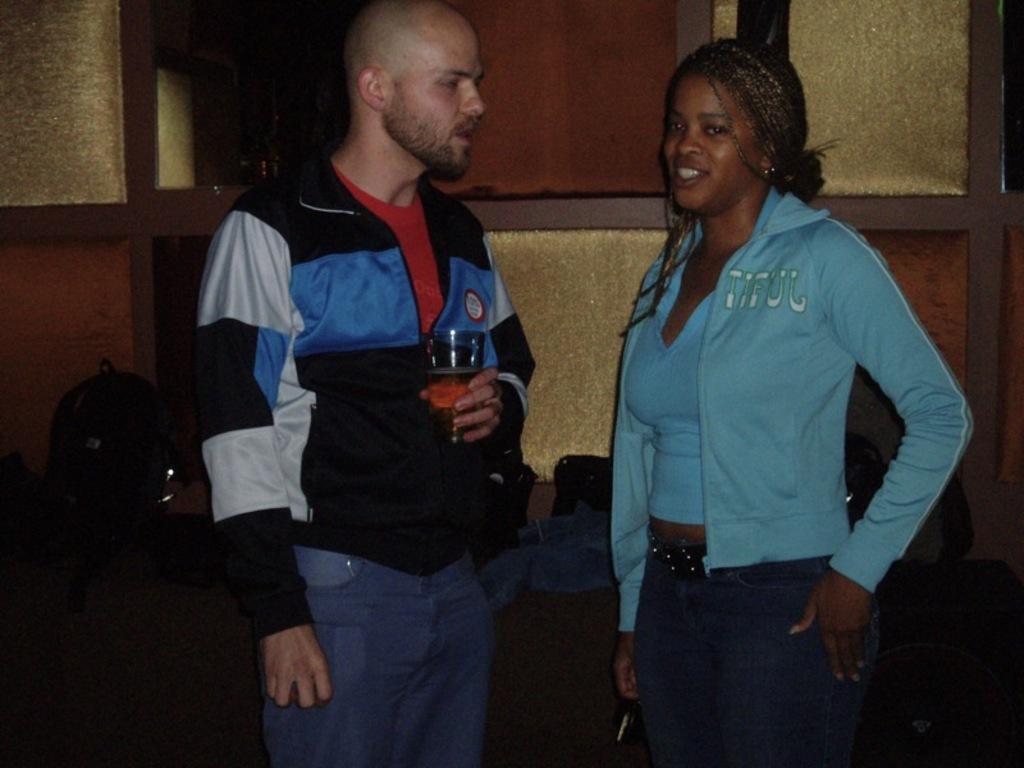Describe this image in one or two sentences. In this picture we can see a man holding a glass with his hand and in front of him we can see a woman smiling and in the background we can see a bag, wall and some objects. 